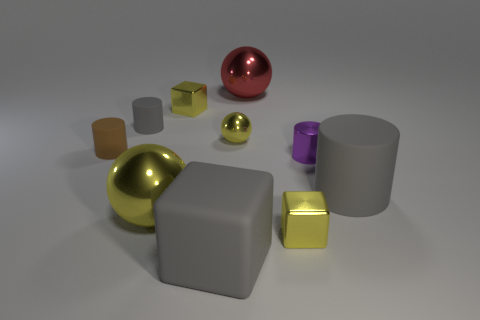Is the number of large rubber blocks behind the red metallic sphere less than the number of yellow metallic balls right of the large gray rubber cylinder?
Provide a short and direct response. No. What is the color of the large matte block?
Provide a short and direct response. Gray. Are there any gray matte blocks that are behind the large gray matte object to the right of the big red shiny thing?
Ensure brevity in your answer.  No. How many purple metal things are the same size as the red metal ball?
Ensure brevity in your answer.  0. How many gray matte cylinders are behind the small brown cylinder in front of the large metallic thing that is right of the large yellow sphere?
Give a very brief answer. 1. What number of small yellow shiny blocks are both in front of the small yellow shiny sphere and behind the small purple metal cylinder?
Your response must be concise. 0. Is there anything else that has the same color as the small sphere?
Offer a very short reply. Yes. How many shiny objects are either tiny things or red spheres?
Your answer should be very brief. 5. What is the yellow cube that is behind the big gray object to the right of the tiny yellow sphere behind the large gray matte cylinder made of?
Your answer should be compact. Metal. What is the tiny cylinder that is on the right side of the metal block behind the large gray matte cylinder made of?
Your answer should be very brief. Metal. 